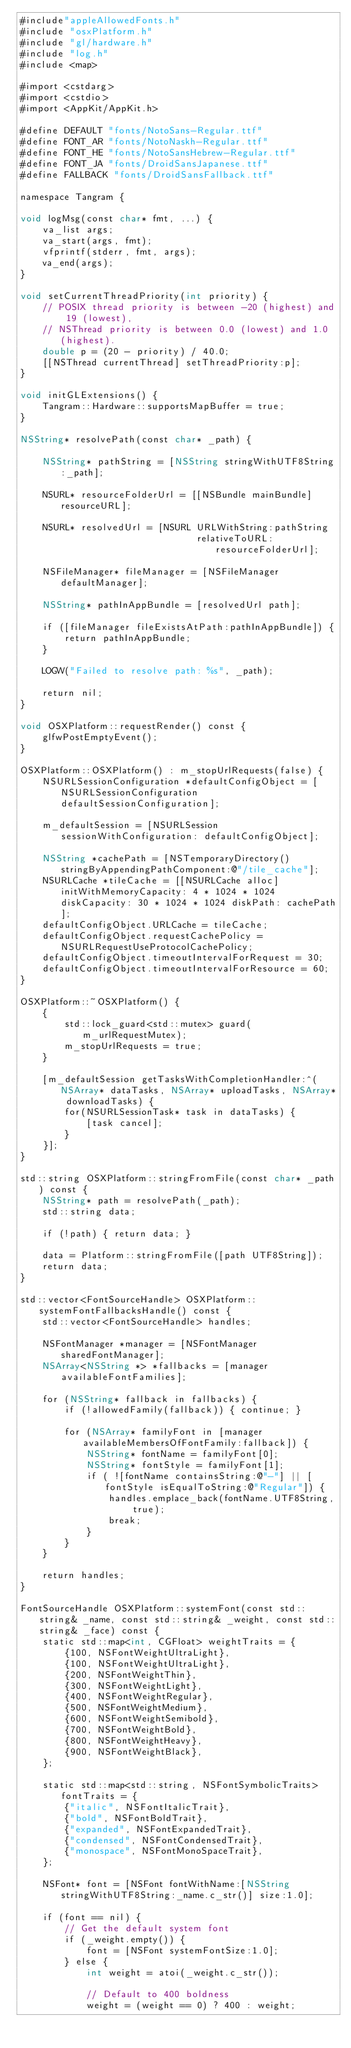Convert code to text. <code><loc_0><loc_0><loc_500><loc_500><_ObjectiveC_>#include"appleAllowedFonts.h"
#include "osxPlatform.h"
#include "gl/hardware.h"
#include "log.h"
#include <map>

#import <cstdarg>
#import <cstdio>
#import <AppKit/AppKit.h>

#define DEFAULT "fonts/NotoSans-Regular.ttf"
#define FONT_AR "fonts/NotoNaskh-Regular.ttf"
#define FONT_HE "fonts/NotoSansHebrew-Regular.ttf"
#define FONT_JA "fonts/DroidSansJapanese.ttf"
#define FALLBACK "fonts/DroidSansFallback.ttf"

namespace Tangram {

void logMsg(const char* fmt, ...) {
    va_list args;
    va_start(args, fmt);
    vfprintf(stderr, fmt, args);
    va_end(args);
}

void setCurrentThreadPriority(int priority) {
    // POSIX thread priority is between -20 (highest) and 19 (lowest),
    // NSThread priority is between 0.0 (lowest) and 1.0 (highest).
    double p = (20 - priority) / 40.0;
    [[NSThread currentThread] setThreadPriority:p];
}

void initGLExtensions() {
    Tangram::Hardware::supportsMapBuffer = true;
}

NSString* resolvePath(const char* _path) {

    NSString* pathString = [NSString stringWithUTF8String:_path];

    NSURL* resourceFolderUrl = [[NSBundle mainBundle] resourceURL];

    NSURL* resolvedUrl = [NSURL URLWithString:pathString
                                relativeToURL:resourceFolderUrl];

    NSFileManager* fileManager = [NSFileManager defaultManager];

    NSString* pathInAppBundle = [resolvedUrl path];

    if ([fileManager fileExistsAtPath:pathInAppBundle]) {
        return pathInAppBundle;
    }

    LOGW("Failed to resolve path: %s", _path);

    return nil;
}

void OSXPlatform::requestRender() const {
    glfwPostEmptyEvent();
}

OSXPlatform::OSXPlatform() : m_stopUrlRequests(false) {
    NSURLSessionConfiguration *defaultConfigObject = [NSURLSessionConfiguration defaultSessionConfiguration];

    m_defaultSession = [NSURLSession sessionWithConfiguration: defaultConfigObject];

    NSString *cachePath = [NSTemporaryDirectory() stringByAppendingPathComponent:@"/tile_cache"];
    NSURLCache *tileCache = [[NSURLCache alloc] initWithMemoryCapacity: 4 * 1024 * 1024 diskCapacity: 30 * 1024 * 1024 diskPath: cachePath];
    defaultConfigObject.URLCache = tileCache;
    defaultConfigObject.requestCachePolicy = NSURLRequestUseProtocolCachePolicy;
    defaultConfigObject.timeoutIntervalForRequest = 30;
    defaultConfigObject.timeoutIntervalForResource = 60;
}

OSXPlatform::~OSXPlatform() {
    {
        std::lock_guard<std::mutex> guard(m_urlRequestMutex);
        m_stopUrlRequests = true;
    }

    [m_defaultSession getTasksWithCompletionHandler:^(NSArray* dataTasks, NSArray* uploadTasks, NSArray* downloadTasks) {
        for(NSURLSessionTask* task in dataTasks) {
            [task cancel];
        }
    }];
}

std::string OSXPlatform::stringFromFile(const char* _path) const {
    NSString* path = resolvePath(_path);
    std::string data;

    if (!path) { return data; }

    data = Platform::stringFromFile([path UTF8String]);
    return data;
}

std::vector<FontSourceHandle> OSXPlatform::systemFontFallbacksHandle() const {
    std::vector<FontSourceHandle> handles;

    NSFontManager *manager = [NSFontManager sharedFontManager];
    NSArray<NSString *> *fallbacks = [manager availableFontFamilies];

    for (NSString* fallback in fallbacks) {
        if (!allowedFamily(fallback)) { continue; }

        for (NSArray* familyFont in [manager availableMembersOfFontFamily:fallback]) {
            NSString* fontName = familyFont[0];
            NSString* fontStyle = familyFont[1];
            if ( ![fontName containsString:@"-"] || [fontStyle isEqualToString:@"Regular"]) {
                handles.emplace_back(fontName.UTF8String, true);
                break;
            }
        }
    }

    return handles;
}

FontSourceHandle OSXPlatform::systemFont(const std::string& _name, const std::string& _weight, const std::string& _face) const {
    static std::map<int, CGFloat> weightTraits = {
        {100, NSFontWeightUltraLight},
        {100, NSFontWeightUltraLight},
        {200, NSFontWeightThin},
        {300, NSFontWeightLight},
        {400, NSFontWeightRegular},
        {500, NSFontWeightMedium},
        {600, NSFontWeightSemibold},
        {700, NSFontWeightBold},
        {800, NSFontWeightHeavy},
        {900, NSFontWeightBlack},
    };

    static std::map<std::string, NSFontSymbolicTraits> fontTraits = {
        {"italic", NSFontItalicTrait},
        {"bold", NSFontBoldTrait},
        {"expanded", NSFontExpandedTrait},
        {"condensed", NSFontCondensedTrait},
        {"monospace", NSFontMonoSpaceTrait},
    };

    NSFont* font = [NSFont fontWithName:[NSString stringWithUTF8String:_name.c_str()] size:1.0];

    if (font == nil) {
        // Get the default system font
        if (_weight.empty()) {
            font = [NSFont systemFontSize:1.0];
        } else {
            int weight = atoi(_weight.c_str());

            // Default to 400 boldness
            weight = (weight == 0) ? 400 : weight;
</code> 